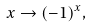<formula> <loc_0><loc_0><loc_500><loc_500>x \rightarrow ( - 1 ) ^ { x } ,</formula> 